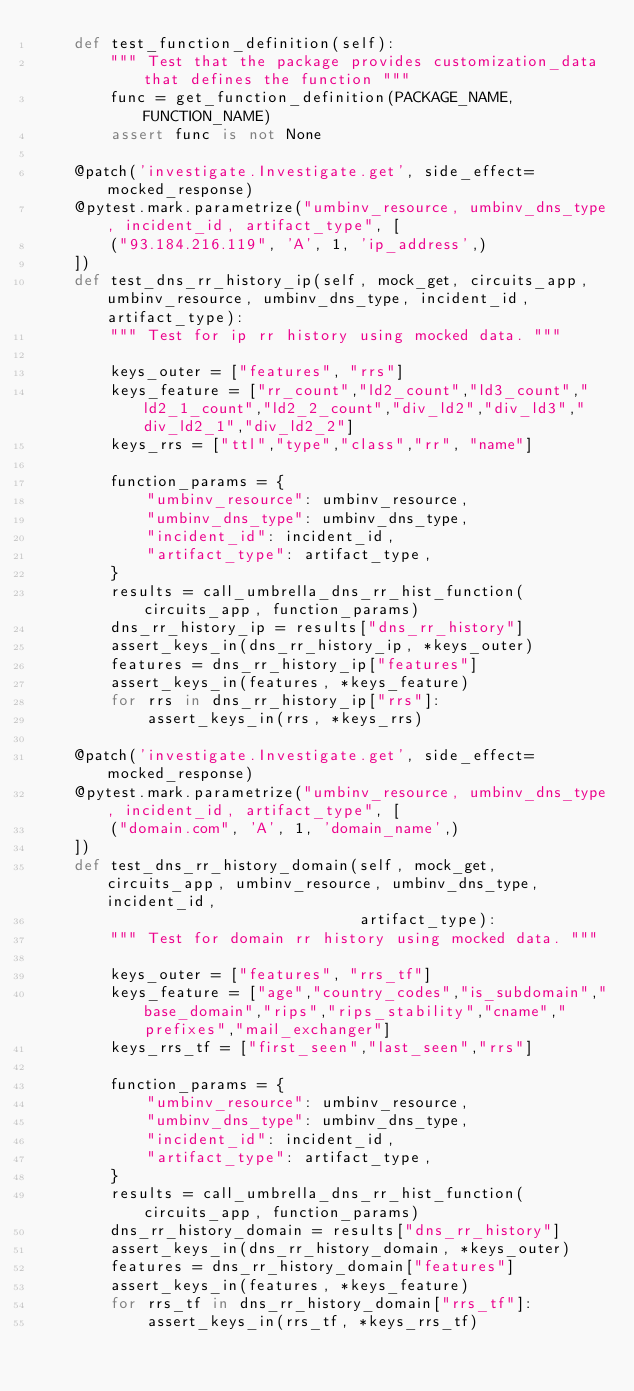<code> <loc_0><loc_0><loc_500><loc_500><_Python_>    def test_function_definition(self):
        """ Test that the package provides customization_data that defines the function """
        func = get_function_definition(PACKAGE_NAME, FUNCTION_NAME)
        assert func is not None

    @patch('investigate.Investigate.get', side_effect=mocked_response)
    @pytest.mark.parametrize("umbinv_resource, umbinv_dns_type, incident_id, artifact_type", [
        ("93.184.216.119", 'A', 1, 'ip_address',)
    ])
    def test_dns_rr_history_ip(self, mock_get, circuits_app, umbinv_resource, umbinv_dns_type, incident_id, artifact_type):
        """ Test for ip rr history using mocked data. """

        keys_outer = ["features", "rrs"]
        keys_feature = ["rr_count","ld2_count","ld3_count","ld2_1_count","ld2_2_count","div_ld2","div_ld3","div_ld2_1","div_ld2_2"]
        keys_rrs = ["ttl","type","class","rr", "name"]

        function_params = {
            "umbinv_resource": umbinv_resource,
            "umbinv_dns_type": umbinv_dns_type,
            "incident_id": incident_id,
            "artifact_type": artifact_type,
        }
        results = call_umbrella_dns_rr_hist_function(circuits_app, function_params)
        dns_rr_history_ip = results["dns_rr_history"]
        assert_keys_in(dns_rr_history_ip, *keys_outer)
        features = dns_rr_history_ip["features"]
        assert_keys_in(features, *keys_feature)
        for rrs in dns_rr_history_ip["rrs"]:
            assert_keys_in(rrs, *keys_rrs)

    @patch('investigate.Investigate.get', side_effect=mocked_response)
    @pytest.mark.parametrize("umbinv_resource, umbinv_dns_type, incident_id, artifact_type", [
        ("domain.com", 'A', 1, 'domain_name',)
    ])
    def test_dns_rr_history_domain(self, mock_get, circuits_app, umbinv_resource, umbinv_dns_type, incident_id,
                                   artifact_type):
        """ Test for domain rr history using mocked data. """

        keys_outer = ["features", "rrs_tf"]
        keys_feature = ["age","country_codes","is_subdomain","base_domain","rips","rips_stability","cname","prefixes","mail_exchanger"]
        keys_rrs_tf = ["first_seen","last_seen","rrs"]

        function_params = {
            "umbinv_resource": umbinv_resource,
            "umbinv_dns_type": umbinv_dns_type,
            "incident_id": incident_id,
            "artifact_type": artifact_type,
        }
        results = call_umbrella_dns_rr_hist_function(circuits_app, function_params)
        dns_rr_history_domain = results["dns_rr_history"]
        assert_keys_in(dns_rr_history_domain, *keys_outer)
        features = dns_rr_history_domain["features"]
        assert_keys_in(features, *keys_feature)
        for rrs_tf in dns_rr_history_domain["rrs_tf"]:
            assert_keys_in(rrs_tf, *keys_rrs_tf)</code> 